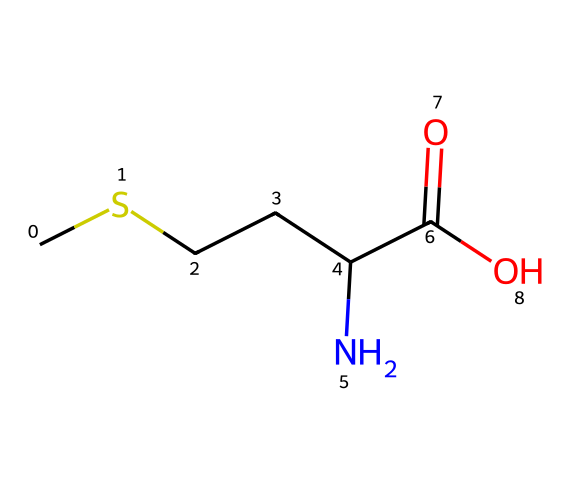What is the name of this amino acid? The chemical structure corresponds to methionine, identified by its SMILES notation where the sulfur atom (S) is part of the chain attached to a carboxylic acid group.
Answer: methionine How many carbon atoms are present in methionine? The SMILES representation shows that there are five carbon atoms (C) in total: three in the chain, one in the amino group, and one in the carboxylic acid.
Answer: five How many nitrogen atoms are present in methionine? The structure shows one nitrogen atom (N) as part of the amino group, which is a characteristic in amino acids.
Answer: one What functional group is represented by C(=O)O in methionine? The C(=O)O in the structure corresponds to a carboxylic acid functional group, characterized by the carbon atom double-bonded to oxygen and single-bonded to a hydroxyl group.
Answer: carboxylic acid What type of chemical compound is methionine? Methionine is classified as an amino acid due to the presence of both an amino group and a carboxylic acid group in its structure.
Answer: amino acid How does the sulfur atom impact methionine's properties? The sulfur atom contributes to the unique properties of methionine, such as its ability to form disulfide bonds, which are important in protein structure and stability.
Answer: disulfide bonds What role does methionine play in brain function? Methionine is a precursor to important neurotransmitters and is involved in methylation processes that are critical for brain function and memory.
Answer: neurotransmitters 